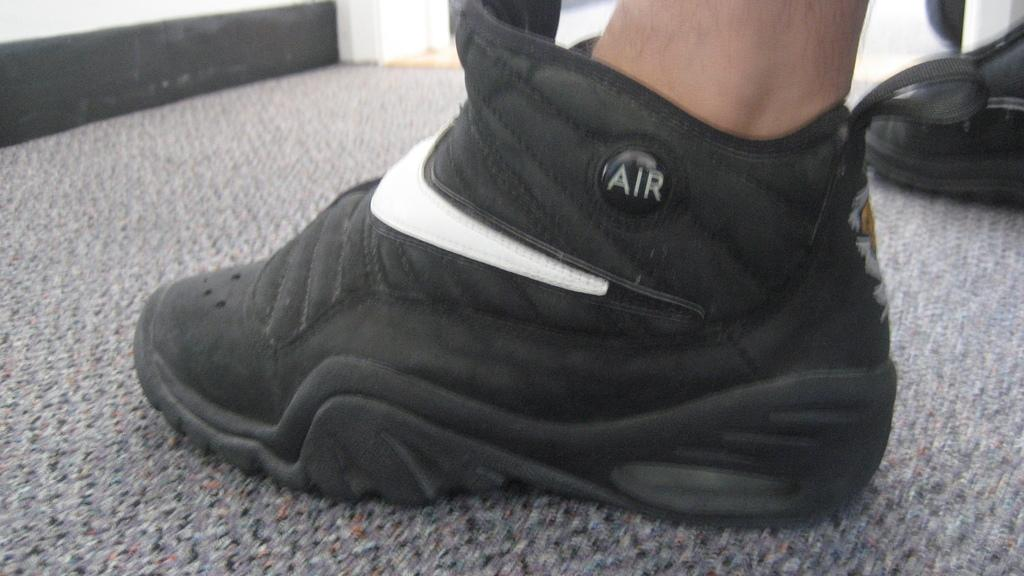What is the primary subject in the image? There is a person in the image. Where is the person located in the image? The person is on the floor. What can be seen in the background of the image? There is a wall in the image. Can you describe the setting of the image? The image may have been taken in a room, as there is a wall visible. What type of copper square can be seen on the wall in the image? There is no copper square present in the image. How many friends are visible in the image? There is only one person visible in the image, so it cannot be determined how many friends are present. 